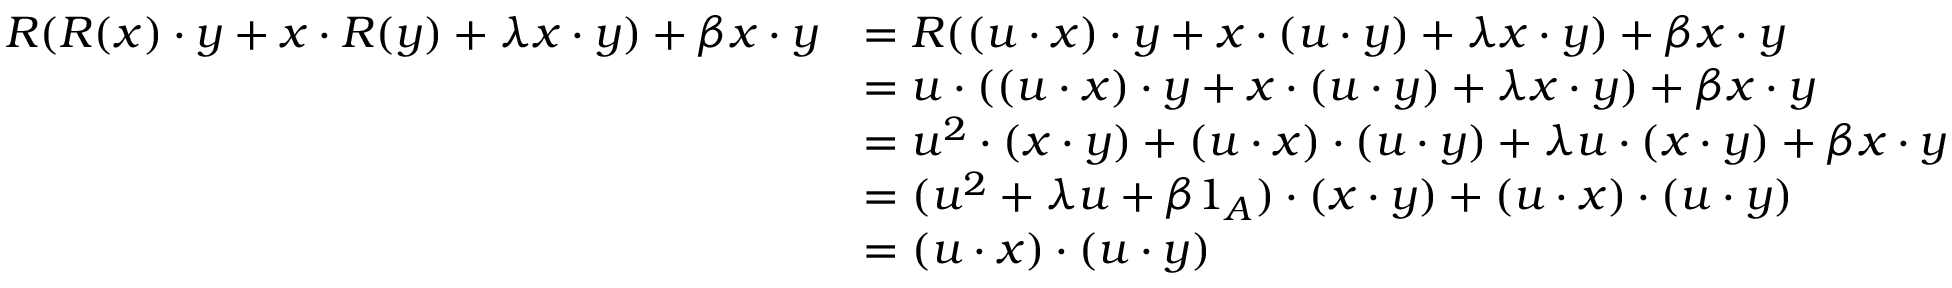<formula> <loc_0><loc_0><loc_500><loc_500>\begin{array} { r l } { R ( R ( x ) \cdot y + x \cdot R ( y ) + \lambda x \cdot y ) + \beta x \cdot y } & { = R ( ( u \cdot x ) \cdot y + x \cdot ( u \cdot y ) + \lambda x \cdot y ) + \beta x \cdot y } \\ & { = u \cdot ( ( u \cdot x ) \cdot y + x \cdot ( u \cdot y ) + \lambda x \cdot y ) + \beta x \cdot y } \\ & { = u ^ { 2 } \cdot ( x \cdot y ) + ( u \cdot x ) \cdot ( u \cdot y ) + \lambda u \cdot ( x \cdot y ) + \beta x \cdot y } \\ & { = ( u ^ { 2 } + \lambda u + \beta 1 _ { A } ) \cdot ( x \cdot y ) + ( u \cdot x ) \cdot ( u \cdot y ) } \\ & { = ( u \cdot x ) \cdot ( u \cdot y ) } \end{array}</formula> 